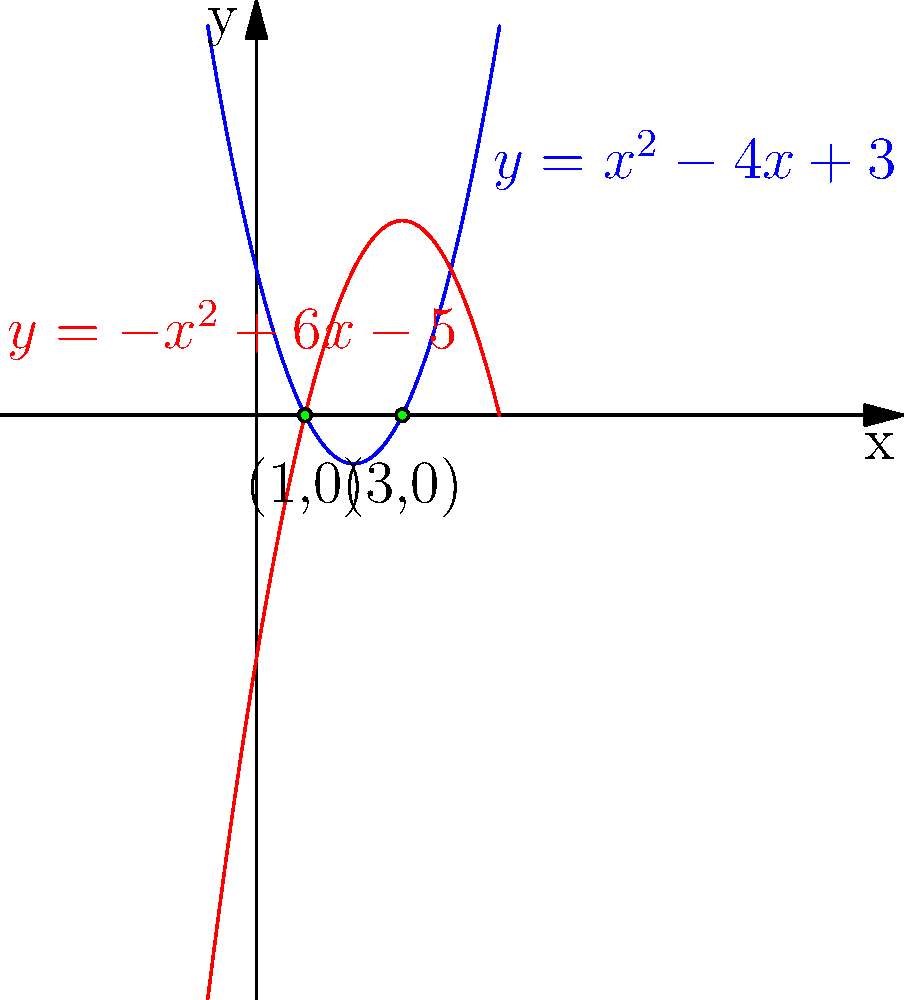As an endocrinologist, you often use mathematical models to analyze hormone levels. Consider two parabolas representing the concentration of two hormones over time: $y = x^2 - 4x + 3$ (blue) and $y = -x^2 + 6x - 5$ (red). Find the x-coordinates of their intersection points, which could indicate times of hormonal balance. To find the intersection points, we need to solve the equation:

$x^2 - 4x + 3 = -x^2 + 6x - 5$

Step 1: Rearrange the equation
$x^2 - 4x + 3 + x^2 - 6x + 5 = 0$

Step 2: Simplify
$2x^2 - 10x + 8 = 0$

Step 3: Divide by 2
$x^2 - 5x + 4 = 0$

Step 4: Use the quadratic formula $x = \frac{-b \pm \sqrt{b^2 - 4ac}}{2a}$
$a = 1$, $b = -5$, $c = 4$

$x = \frac{5 \pm \sqrt{25 - 16}}{2} = \frac{5 \pm 3}{2}$

Step 5: Solve
$x_1 = \frac{5 + 3}{2} = 4 \div 2 = 2$
$x_2 = \frac{5 - 3}{2} = 2 \div 2 = 1$

Therefore, the x-coordinates of the intersection points are 1 and 3.
Answer: $x = 1$ and $x = 3$ 